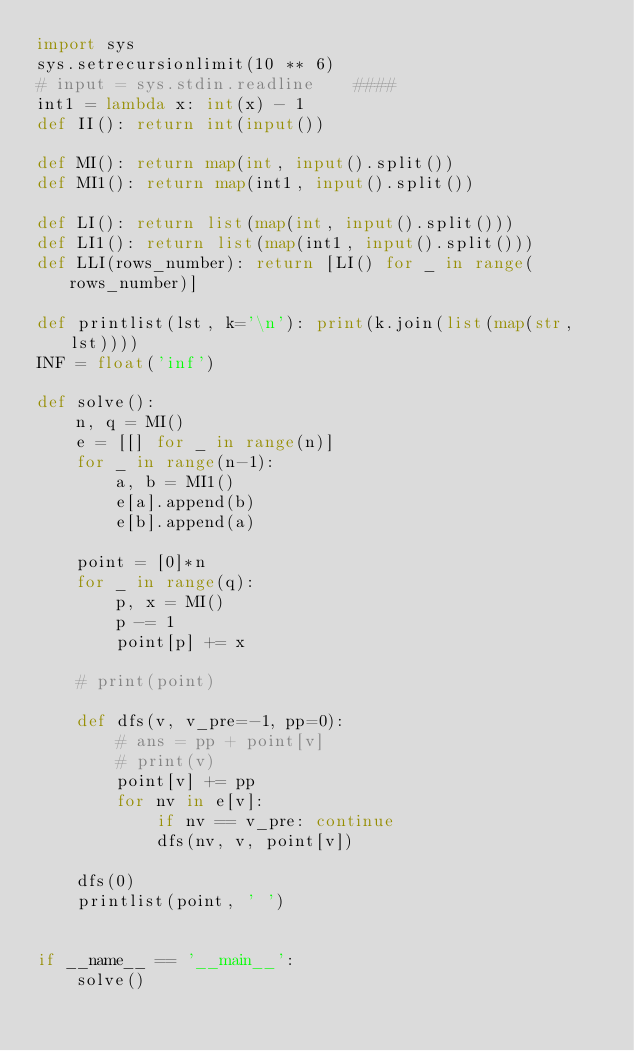Convert code to text. <code><loc_0><loc_0><loc_500><loc_500><_Python_>import sys
sys.setrecursionlimit(10 ** 6)
# input = sys.stdin.readline    ####
int1 = lambda x: int(x) - 1
def II(): return int(input())

def MI(): return map(int, input().split())
def MI1(): return map(int1, input().split())

def LI(): return list(map(int, input().split()))
def LI1(): return list(map(int1, input().split()))
def LLI(rows_number): return [LI() for _ in range(rows_number)]

def printlist(lst, k='\n'): print(k.join(list(map(str, lst))))
INF = float('inf')

def solve():
    n, q = MI()
    e = [[] for _ in range(n)]
    for _ in range(n-1):
        a, b = MI1()
        e[a].append(b)
        e[b].append(a)

    point = [0]*n
    for _ in range(q):
        p, x = MI()
        p -= 1
        point[p] += x

    # print(point)

    def dfs(v, v_pre=-1, pp=0):
        # ans = pp + point[v]
        # print(v)
        point[v] += pp
        for nv in e[v]:
            if nv == v_pre: continue
            dfs(nv, v, point[v])

    dfs(0)
    printlist(point, ' ')


if __name__ == '__main__':
    solve()
</code> 